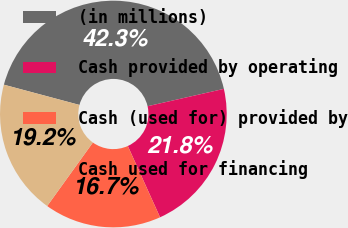Convert chart to OTSL. <chart><loc_0><loc_0><loc_500><loc_500><pie_chart><fcel>(in millions)<fcel>Cash provided by operating<fcel>Cash (used for) provided by<fcel>Cash used for financing<nl><fcel>42.27%<fcel>21.8%<fcel>16.68%<fcel>19.24%<nl></chart> 